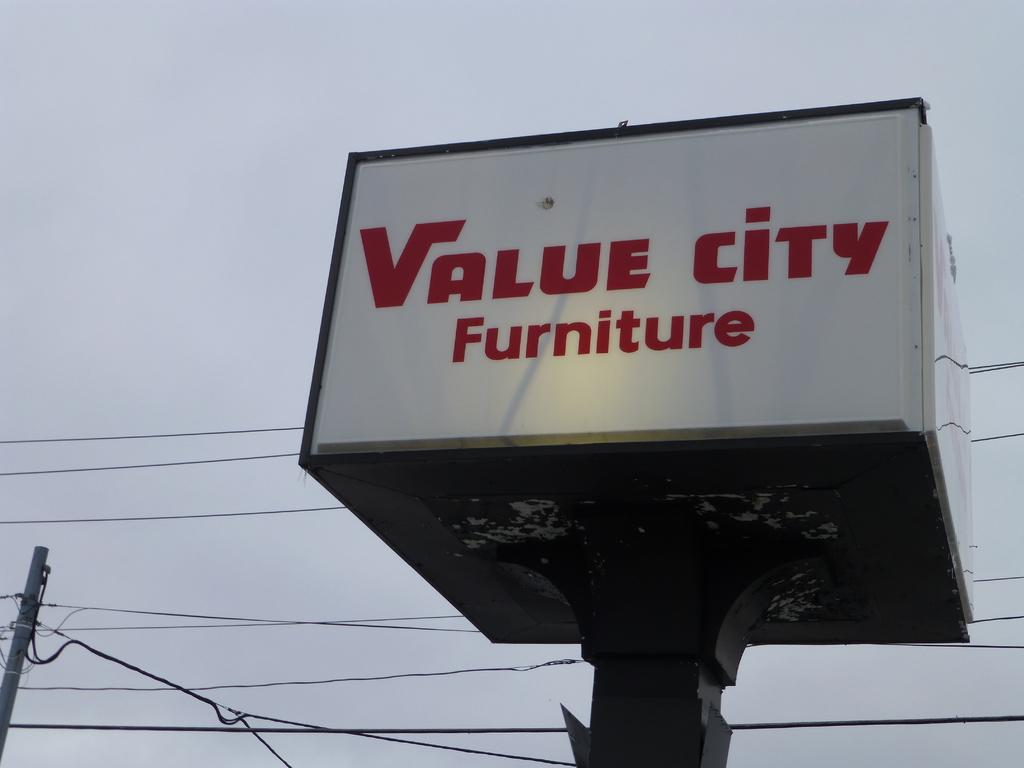<image>
Give a short and clear explanation of the subsequent image. A large sign that says Value city Furniture is next to power lines. 